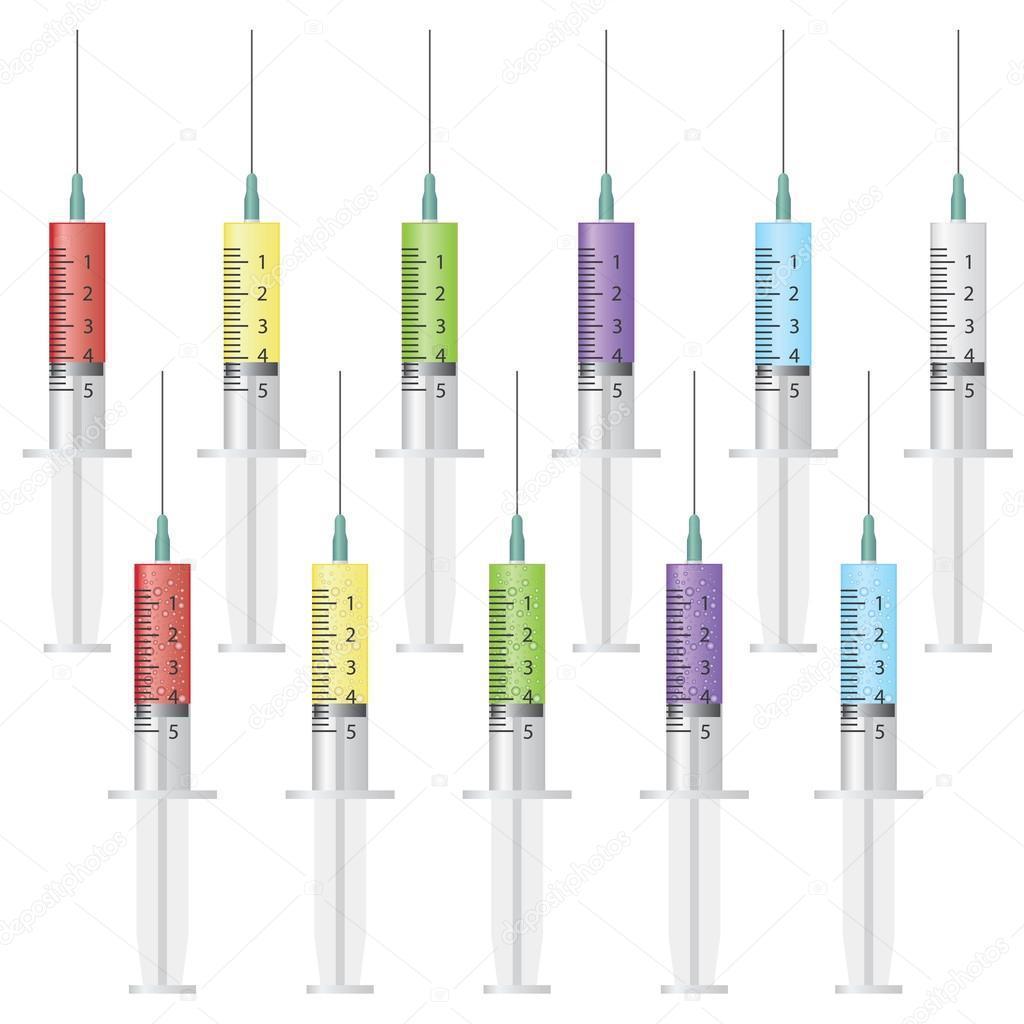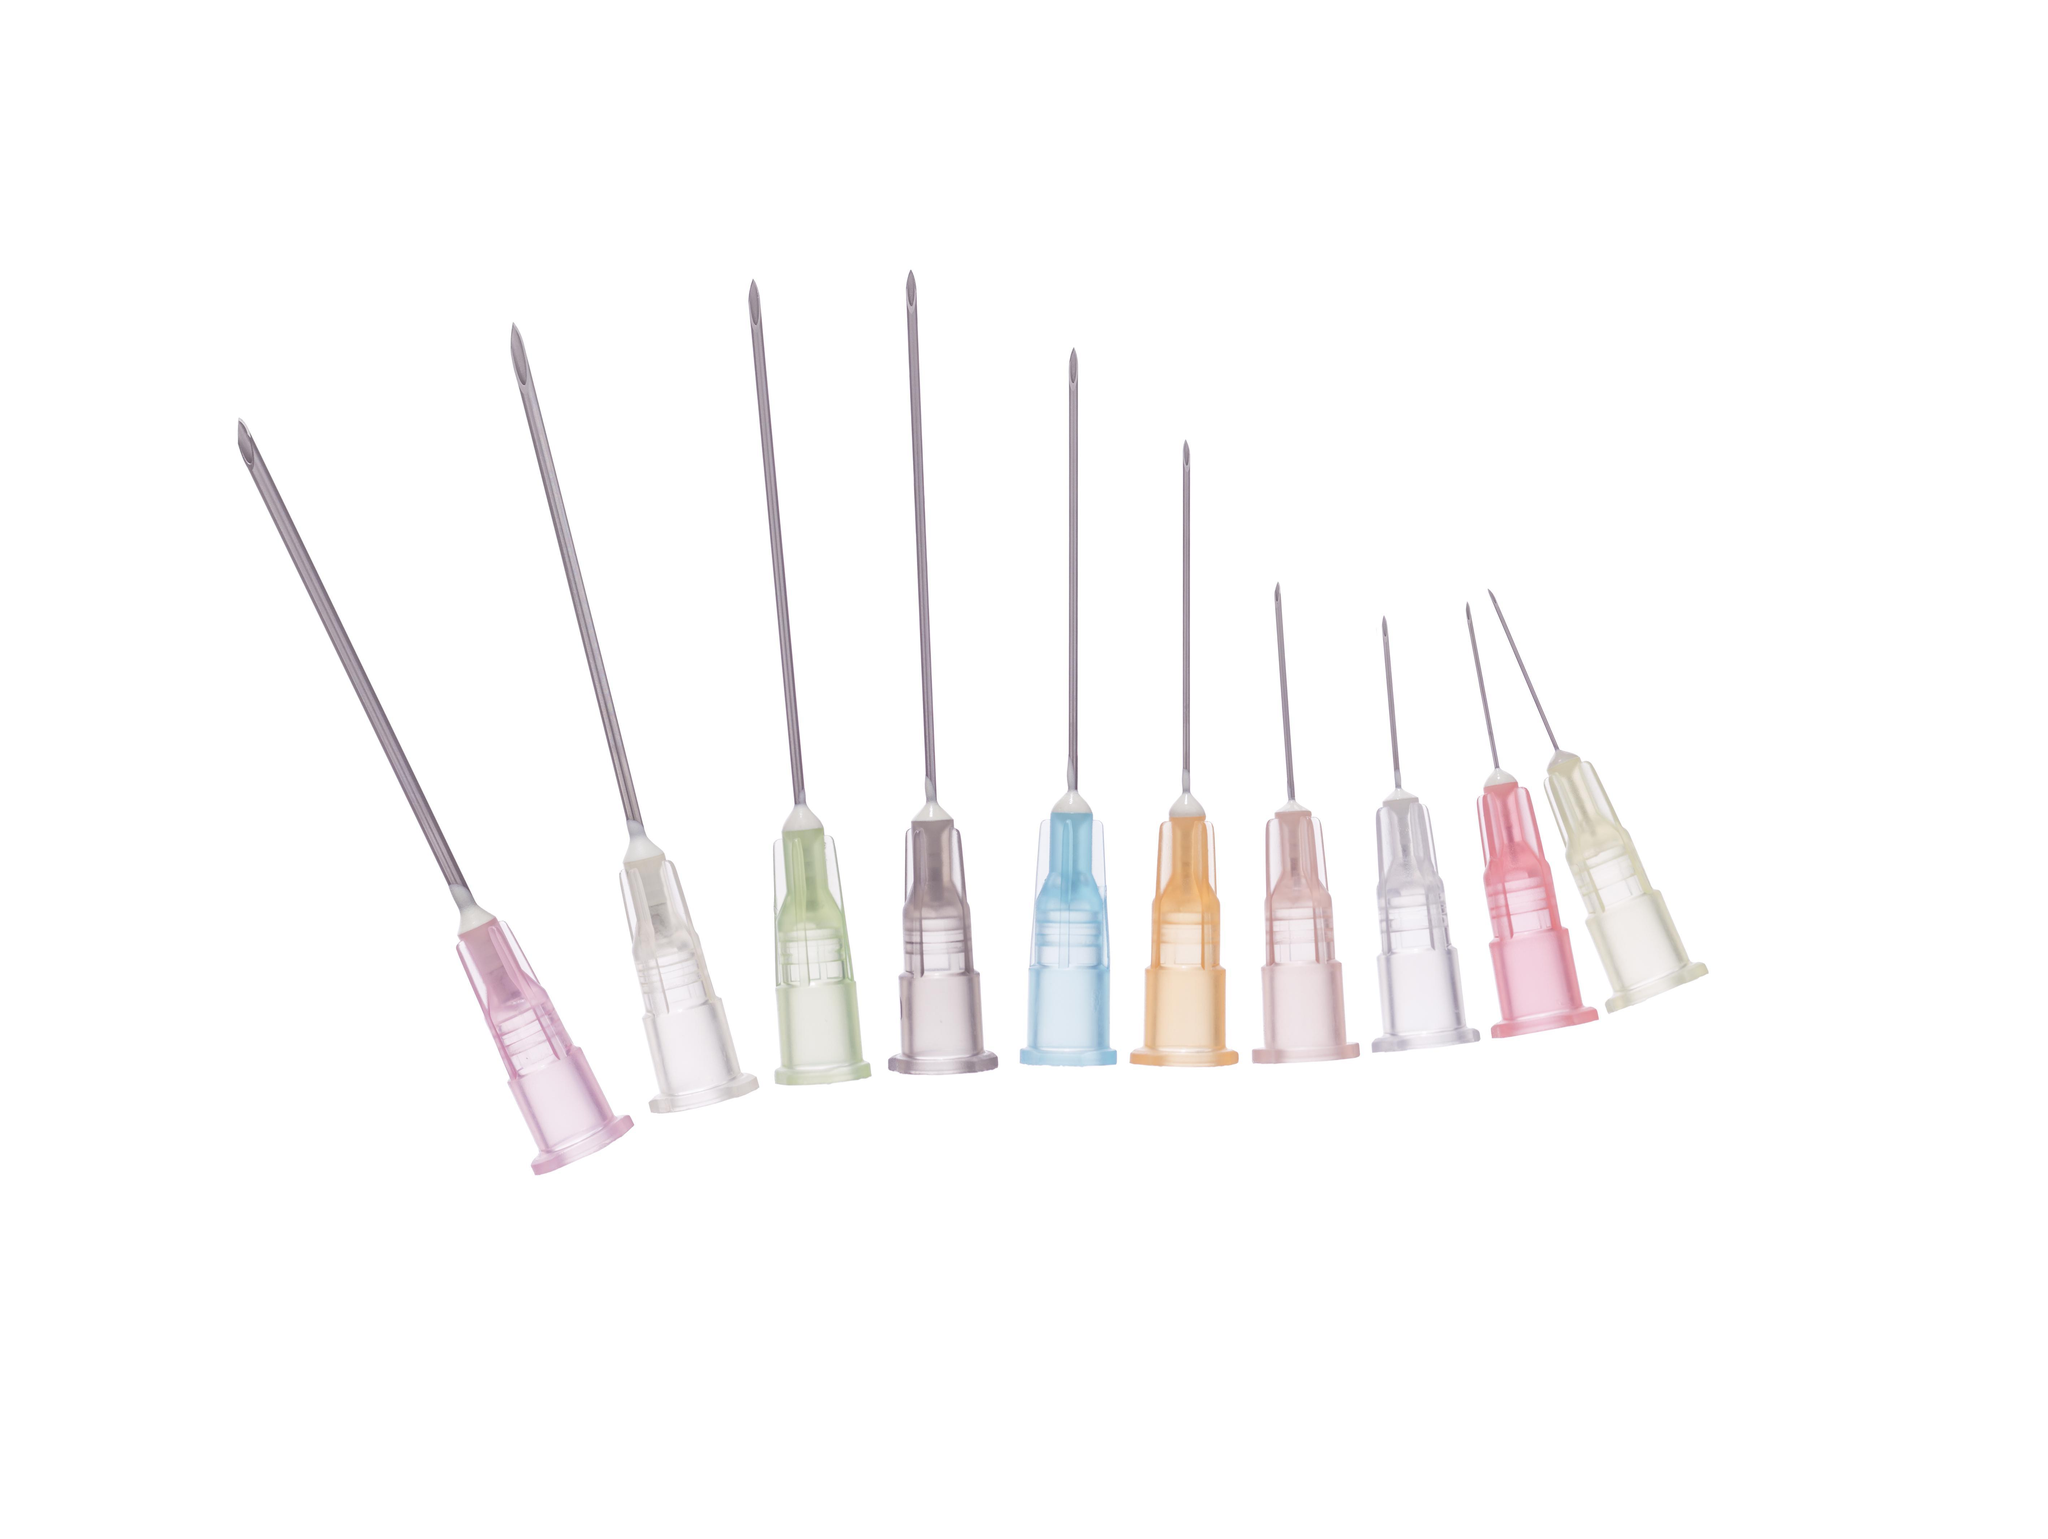The first image is the image on the left, the second image is the image on the right. Assess this claim about the two images: "The left and right image contains a total of nine syringes.". Correct or not? Answer yes or no. No. The first image is the image on the left, the second image is the image on the right. Given the left and right images, does the statement "The left image is a row of needless syringes pointed downward." hold true? Answer yes or no. No. 